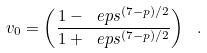Convert formula to latex. <formula><loc_0><loc_0><loc_500><loc_500>v _ { 0 } = \left ( \frac { 1 - \ e p s ^ { ( 7 - p ) / 2 } } { 1 + \ e p s ^ { ( 7 - p ) / 2 } } \right ) \ .</formula> 